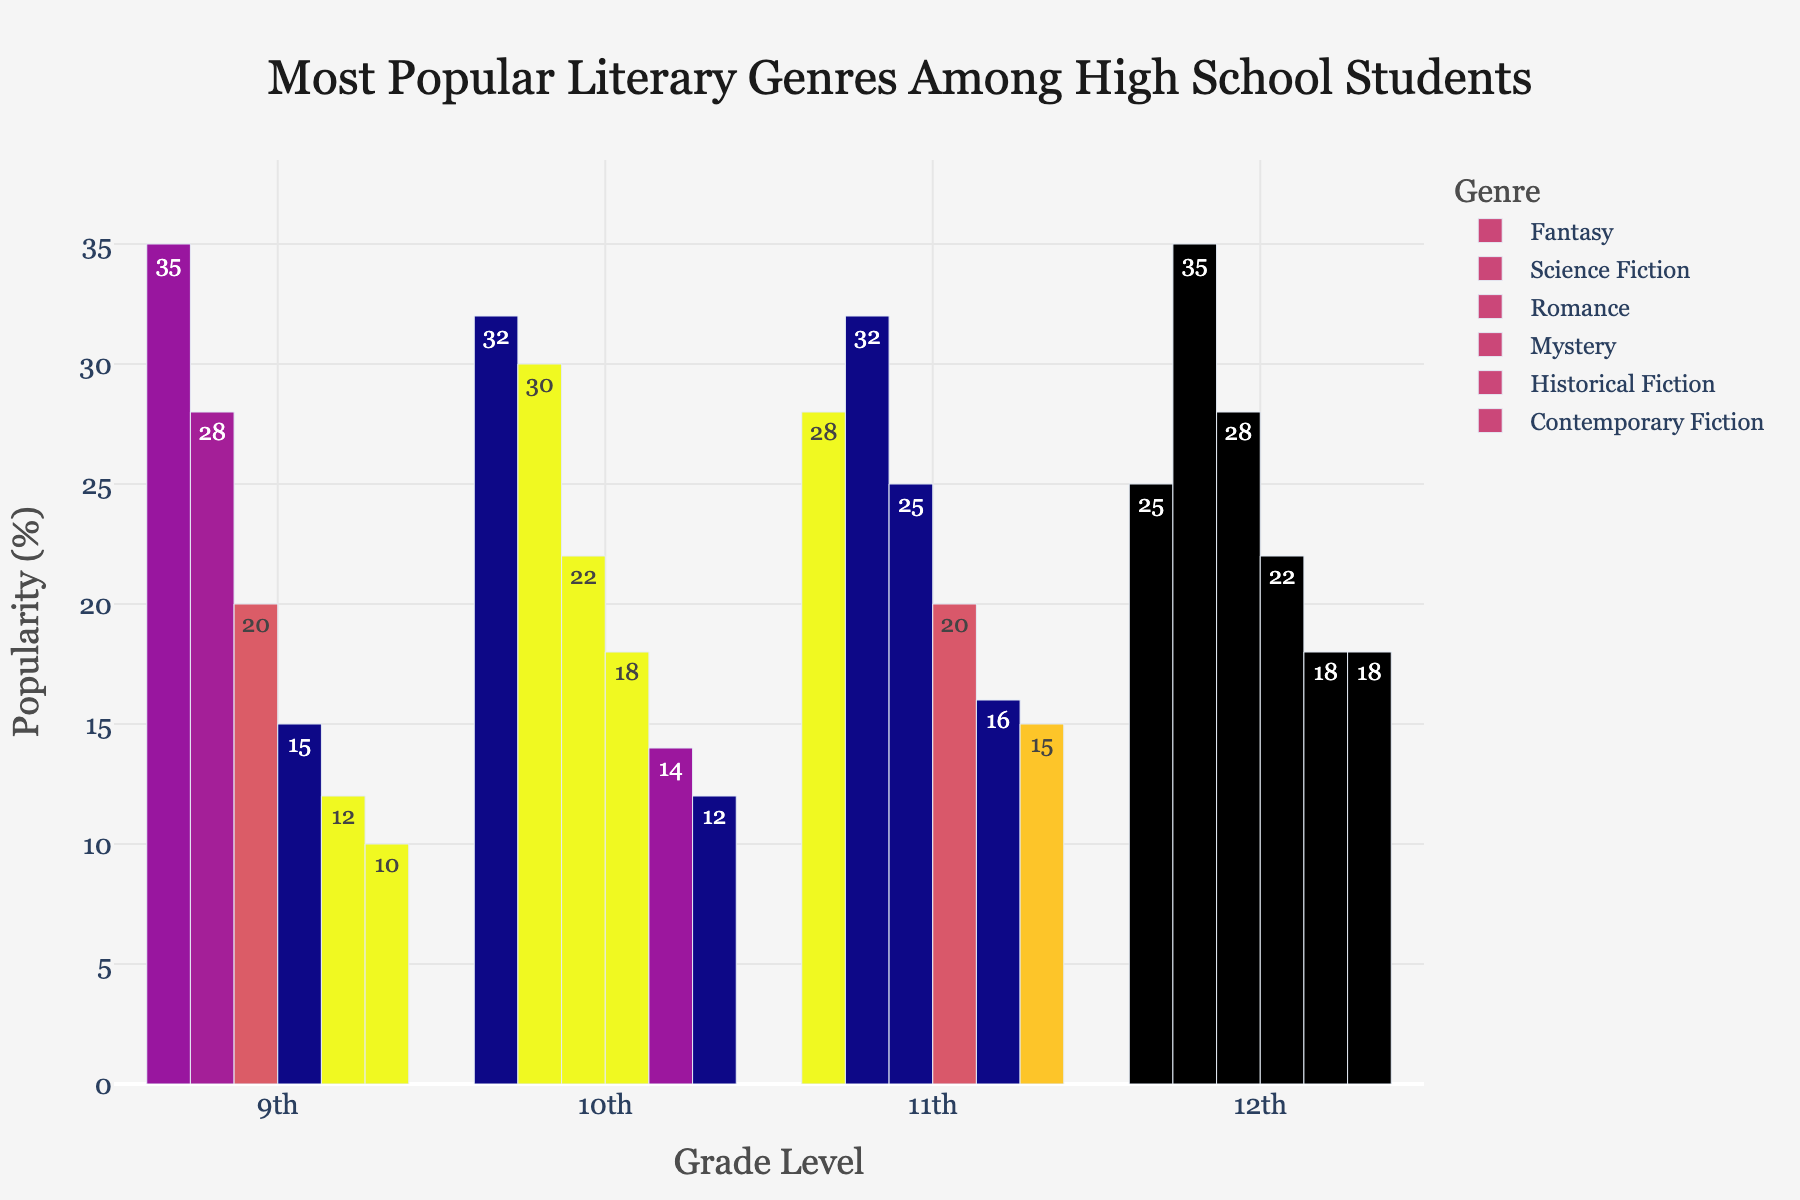What genre is most popular among 11th-grade students? The bar chart shows the popularity of various literary genres by grade level. For 11th graders, Science Fiction has the tallest bar, indicating it's the most popular genre in that grade.
Answer: Science Fiction Which genre sees an increase in popularity as students progress from 9th to 12th grade? By visually comparing the bars from 9th to 12th grade, it can be observed that Science Fiction increases in size, indicating a rise in popularity.
Answer: Science Fiction What is the least popular genre among 12th-grade students? The bar for Contemporary Fiction (10) among 12th graders is the shortest, making it the least popular genre for that grade.
Answer: Contemporary Fiction Are there any grades where Fantasy is not the most popular genre? By examining the height of the Fantasy bars for all grade levels, it can be seen that Fantasy is not the most popular in 11th and 12th grade, where Science Fiction exceeds it.
Answer: Yes, in 11th and 12th grades What is the total popularity percentage of Romance from 9th to 12th grade? The percentages for Romance in each grade level are: 20 (9th) + 22 (10th) + 25 (11th) + 28 (12th). Summing these values gives 95.
Answer: 95% Which grade shows the highest popularity for Historical Fiction? By comparing the Historical Fiction bars across all grades, 12th grade has the tallest bar, indicating the highest popularity at 18%.
Answer: 12th grade How does the popularity of Mystery change as students move from 9th grade to 12th grade? The heights of the Mystery bars increase consistently: 15 (9th), 18 (10th), 20 (11th), and 22 (12th), showing a steady increase in popularity.
Answer: Increases What is the difference in popularity between Science Fiction and Fantasy among 12th graders? The bar for Science Fiction (35) and Fantasy (25) among 12th graders suggest a difference of 35 - 25 = 10.
Answer: 10% Which genre is the least popular overall across all grades combined? By visually evaluating each genre across all grades, Contemporary Fiction appears to have the lowest bars in general, making it the least popular overall.
Answer: Contemporary Fiction For which grade does Contemporary Fiction have the same popularity as another genre? In 12th grade, both Contemporary Fiction and Historical Fiction are at 18%. By reviewing the visual bars, it is evident that they are equal in height.
Answer: 12th grade 